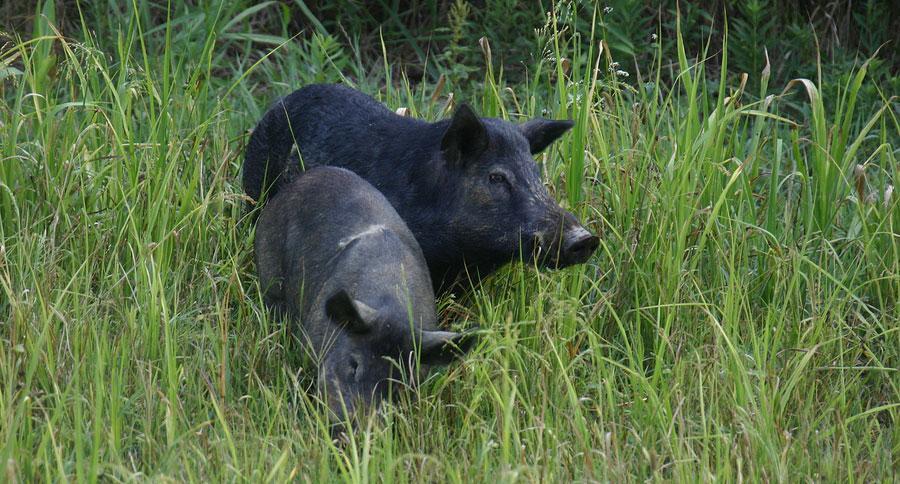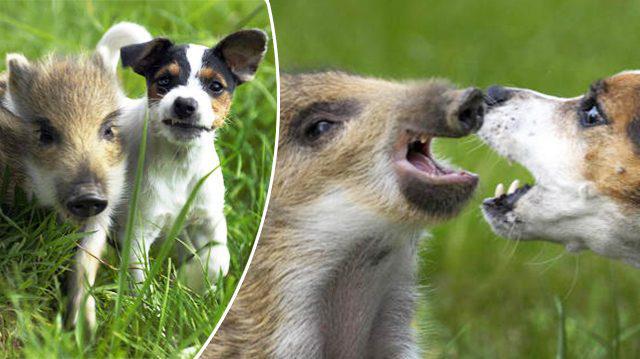The first image is the image on the left, the second image is the image on the right. Examine the images to the left and right. Is the description "One pig is moving across the pavement." accurate? Answer yes or no. No. 